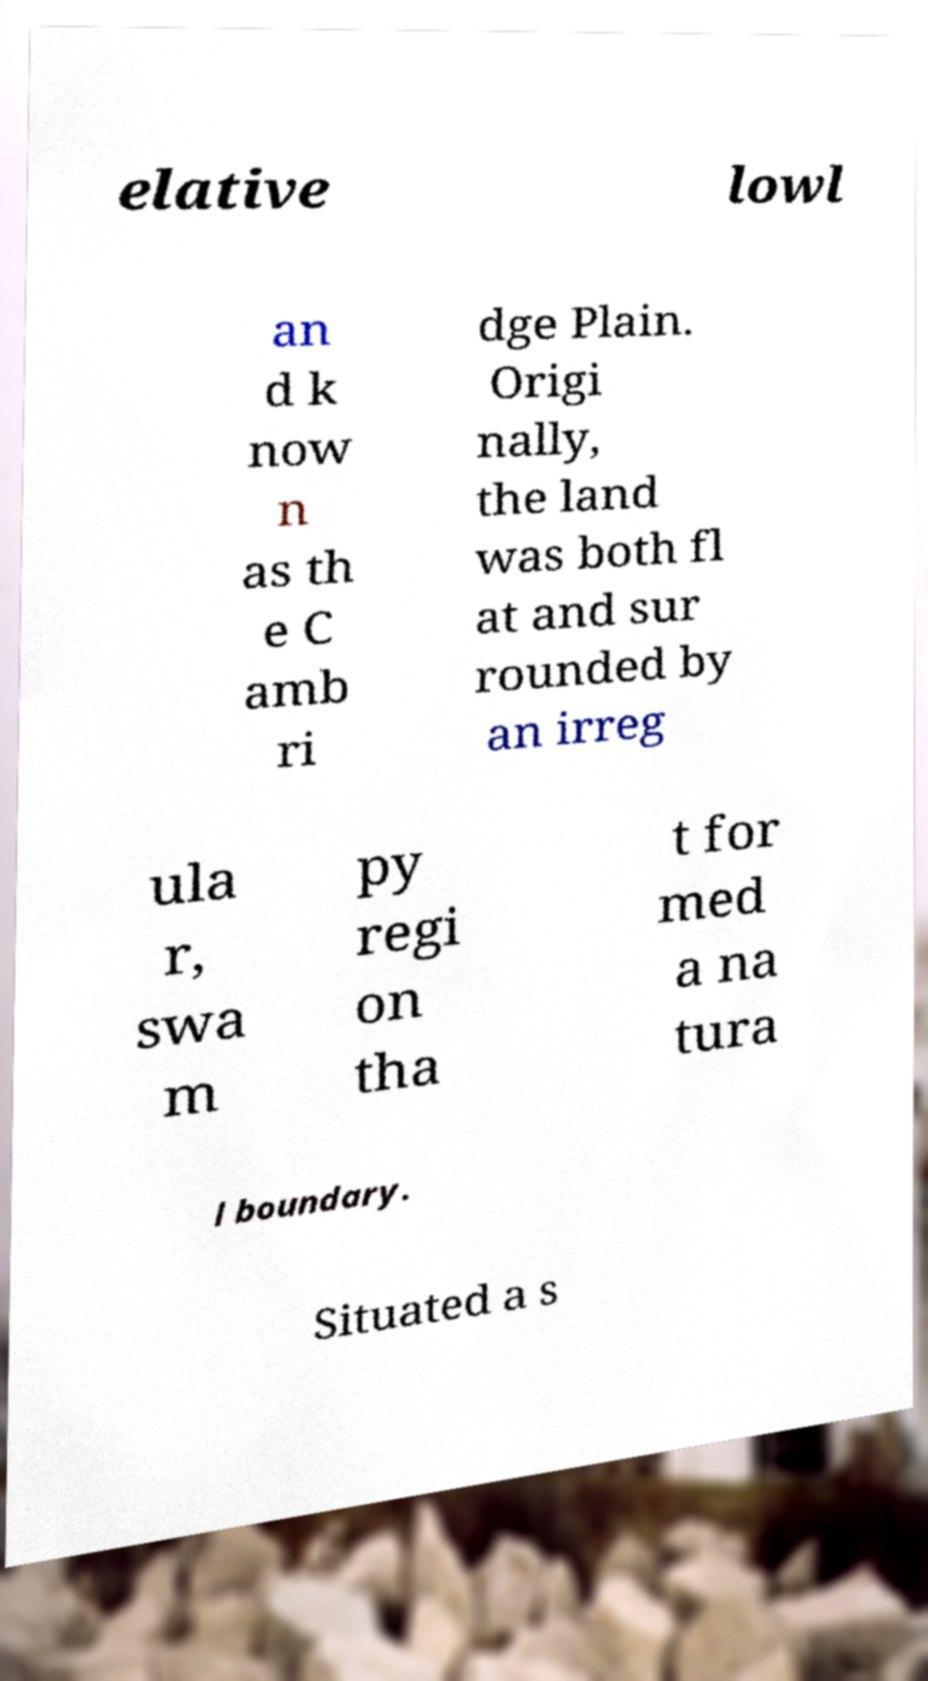There's text embedded in this image that I need extracted. Can you transcribe it verbatim? elative lowl an d k now n as th e C amb ri dge Plain. Origi nally, the land was both fl at and sur rounded by an irreg ula r, swa m py regi on tha t for med a na tura l boundary. Situated a s 